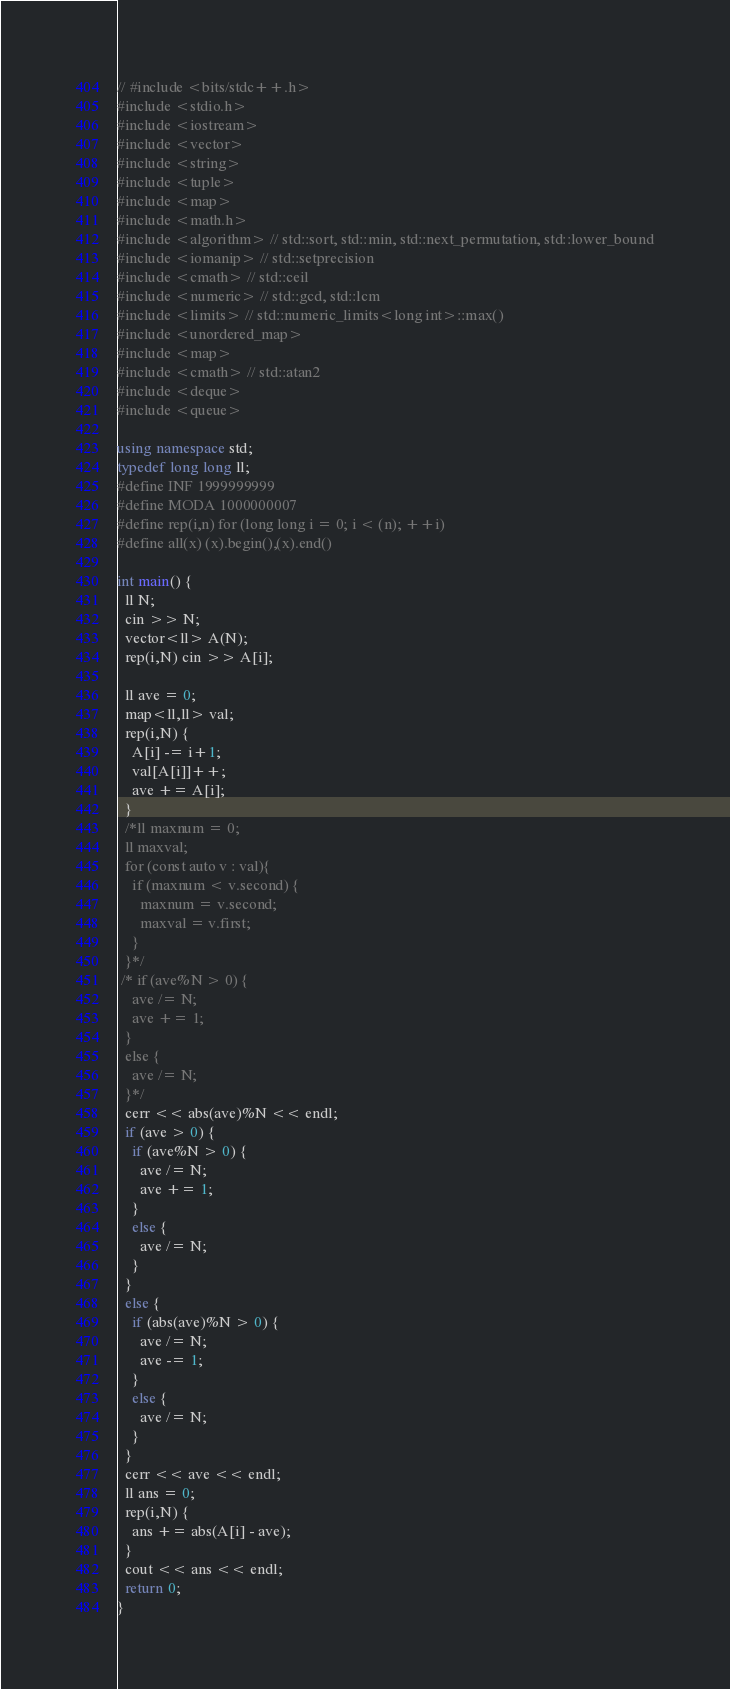<code> <loc_0><loc_0><loc_500><loc_500><_C++_>// #include <bits/stdc++.h>
#include <stdio.h>
#include <iostream>
#include <vector>
#include <string>
#include <tuple>
#include <map>
#include <math.h>
#include <algorithm> // std::sort, std::min, std::next_permutation, std::lower_bound
#include <iomanip> // std::setprecision
#include <cmath> // std::ceil
#include <numeric> // std::gcd, std::lcm
#include <limits> // std::numeric_limits<long int>::max()
#include <unordered_map>
#include <map>
#include <cmath> // std::atan2
#include <deque>
#include <queue>

using namespace std;
typedef long long ll;
#define INF 1999999999
#define MODA 1000000007 
#define rep(i,n) for (long long i = 0; i < (n); ++i)
#define all(x) (x).begin(),(x).end()

int main() {
  ll N;
  cin >> N;
  vector<ll> A(N);
  rep(i,N) cin >> A[i];
  
  ll ave = 0;
  map<ll,ll> val;
  rep(i,N) {
    A[i] -= i+1;
    val[A[i]]++;
    ave += A[i];
  }
  /*ll maxnum = 0;
  ll maxval;
  for (const auto v : val){
    if (maxnum < v.second) {
      maxnum = v.second;
      maxval = v.first;
    }
  }*/
 /* if (ave%N > 0) {
    ave /= N;
    ave += 1;
  }
  else {
    ave /= N;
  }*/
  cerr << abs(ave)%N << endl;
  if (ave > 0) {
    if (ave%N > 0) {
      ave /= N;
      ave += 1;
    }
    else {
      ave /= N;
    }
  }
  else {
    if (abs(ave)%N > 0) {
      ave /= N;
      ave -= 1;
    }
    else {
      ave /= N;
    }
  }    
  cerr << ave << endl;
  ll ans = 0;
  rep(i,N) {
    ans += abs(A[i] - ave);
  }
  cout << ans << endl;
  return 0;
}
</code> 